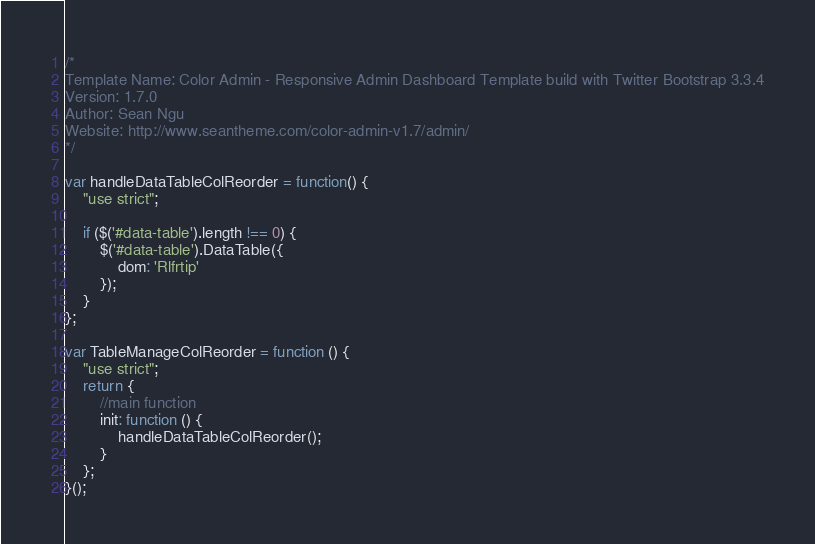<code> <loc_0><loc_0><loc_500><loc_500><_JavaScript_>/*   
Template Name: Color Admin - Responsive Admin Dashboard Template build with Twitter Bootstrap 3.3.4
Version: 1.7.0
Author: Sean Ngu
Website: http://www.seantheme.com/color-admin-v1.7/admin/
*/

var handleDataTableColReorder = function() {
	"use strict";
    
    if ($('#data-table').length !== 0) {
        $('#data-table').DataTable({
            dom: 'Rlfrtip'
        });
    }
};

var TableManageColReorder = function () {
	"use strict";
    return {
        //main function
        init: function () {
            handleDataTableColReorder();
        }
    };
}();</code> 